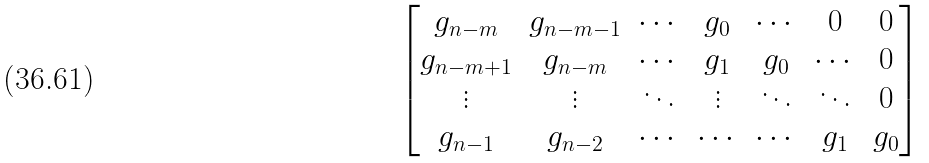Convert formula to latex. <formula><loc_0><loc_0><loc_500><loc_500>\begin{bmatrix} g _ { n - m } & g _ { n - m - 1 } & \cdots & g _ { 0 } & \cdots & 0 & 0 \\ g _ { n - m + 1 } & g _ { n - m } & \cdots & g _ { 1 } & g _ { 0 } & \cdots & 0 \\ \vdots & \vdots & \ddots & \vdots & \ddots & \ddots & 0 \\ g _ { n - 1 } & g _ { n - 2 } & \cdots & \cdots & \cdots & g _ { 1 } & g _ { 0 } \end{bmatrix}</formula> 